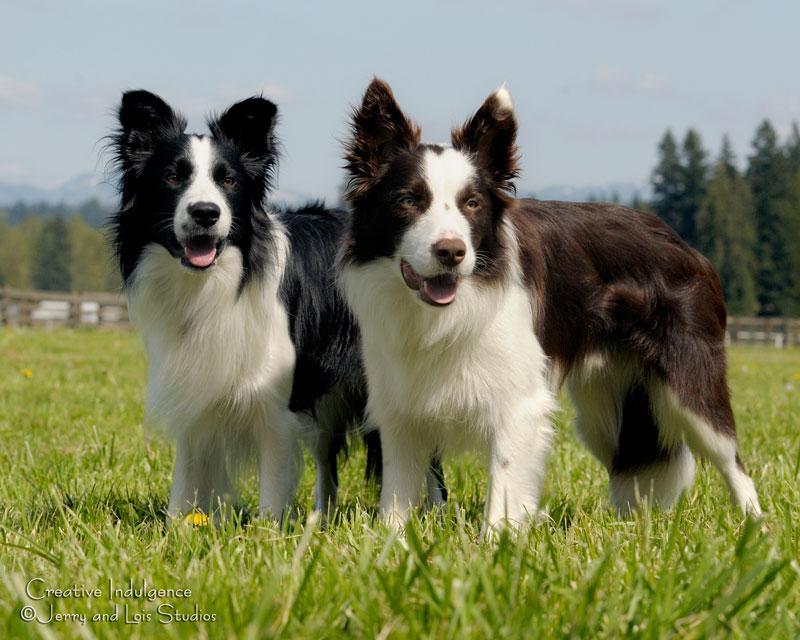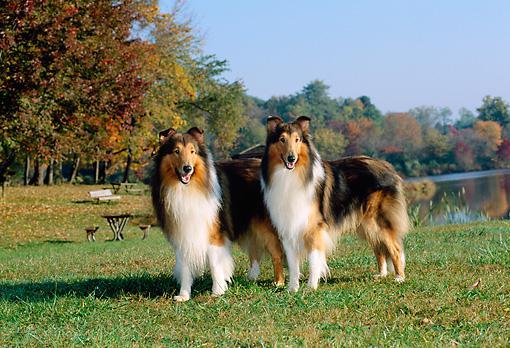The first image is the image on the left, the second image is the image on the right. For the images shown, is this caption "There are four adult collies sitting next to each other." true? Answer yes or no. No. The first image is the image on the left, the second image is the image on the right. Examine the images to the left and right. Is the description "An image shows exactly two collie dogs posed outdoors, with one reclining at the left of a dog sitting upright." accurate? Answer yes or no. No. 